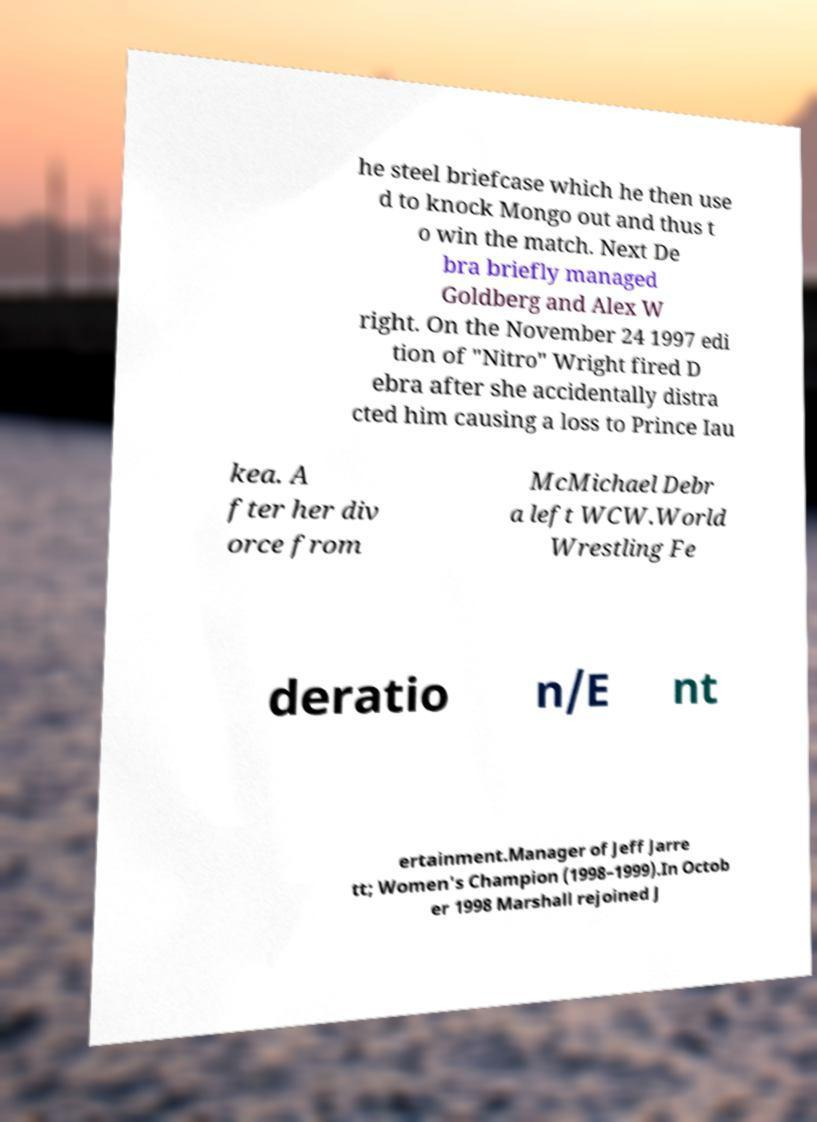Please read and relay the text visible in this image. What does it say? he steel briefcase which he then use d to knock Mongo out and thus t o win the match. Next De bra briefly managed Goldberg and Alex W right. On the November 24 1997 edi tion of "Nitro" Wright fired D ebra after she accidentally distra cted him causing a loss to Prince Iau kea. A fter her div orce from McMichael Debr a left WCW.World Wrestling Fe deratio n/E nt ertainment.Manager of Jeff Jarre tt; Women's Champion (1998–1999).In Octob er 1998 Marshall rejoined J 